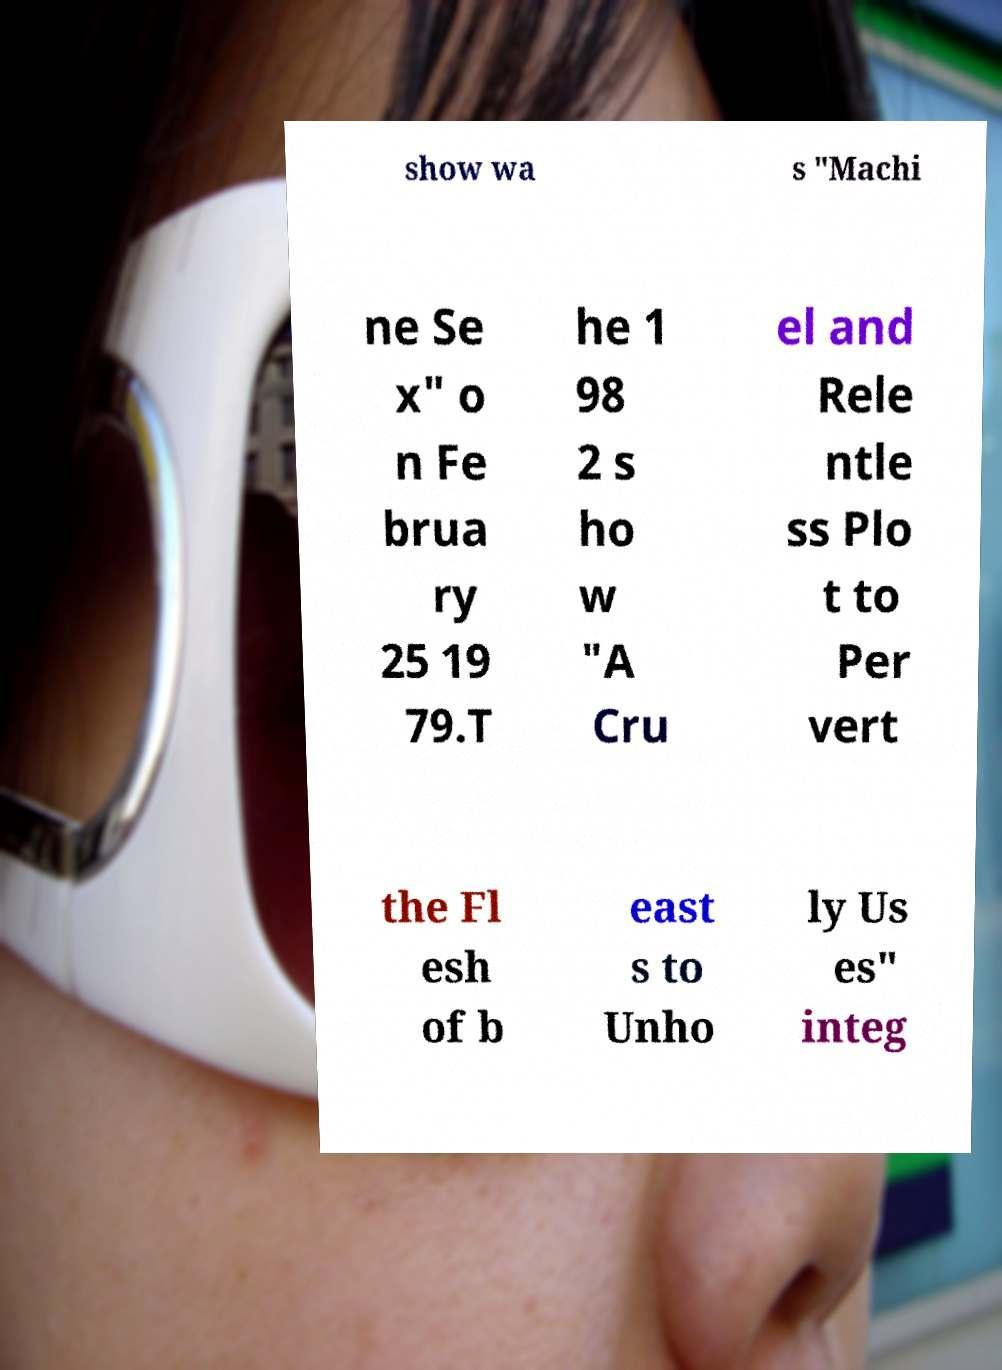Please identify and transcribe the text found in this image. show wa s "Machi ne Se x" o n Fe brua ry 25 19 79.T he 1 98 2 s ho w "A Cru el and Rele ntle ss Plo t to Per vert the Fl esh of b east s to Unho ly Us es" integ 